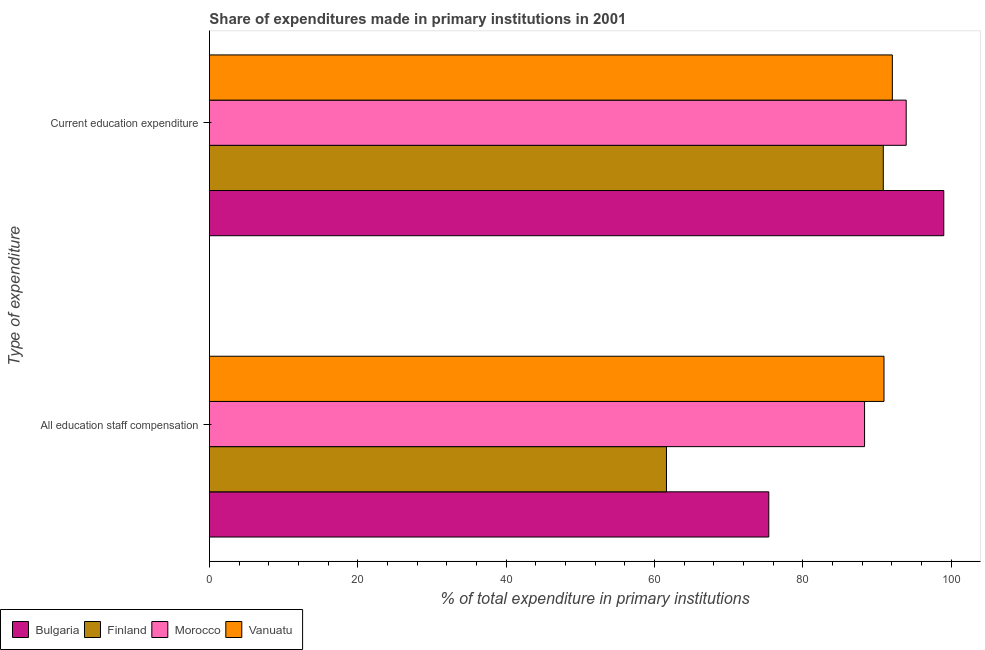How many bars are there on the 2nd tick from the bottom?
Provide a short and direct response. 4. What is the label of the 2nd group of bars from the top?
Your response must be concise. All education staff compensation. What is the expenditure in staff compensation in Morocco?
Offer a very short reply. 88.34. Across all countries, what is the maximum expenditure in staff compensation?
Ensure brevity in your answer.  90.96. Across all countries, what is the minimum expenditure in staff compensation?
Your answer should be compact. 61.63. In which country was the expenditure in staff compensation maximum?
Provide a succinct answer. Vanuatu. In which country was the expenditure in education minimum?
Your answer should be very brief. Finland. What is the total expenditure in education in the graph?
Give a very brief answer. 375.93. What is the difference between the expenditure in education in Morocco and that in Finland?
Your answer should be very brief. 3.09. What is the difference between the expenditure in education in Finland and the expenditure in staff compensation in Vanuatu?
Provide a succinct answer. -0.09. What is the average expenditure in education per country?
Keep it short and to the point. 93.98. What is the difference between the expenditure in education and expenditure in staff compensation in Morocco?
Your answer should be compact. 5.61. What is the ratio of the expenditure in education in Bulgaria to that in Finland?
Keep it short and to the point. 1.09. Is the expenditure in education in Finland less than that in Morocco?
Your answer should be compact. Yes. What does the 3rd bar from the top in All education staff compensation represents?
Provide a succinct answer. Finland. What does the 1st bar from the bottom in All education staff compensation represents?
Offer a very short reply. Bulgaria. How many bars are there?
Offer a terse response. 8. Are all the bars in the graph horizontal?
Make the answer very short. Yes. How many legend labels are there?
Provide a short and direct response. 4. How are the legend labels stacked?
Make the answer very short. Horizontal. What is the title of the graph?
Offer a very short reply. Share of expenditures made in primary institutions in 2001. Does "Bosnia and Herzegovina" appear as one of the legend labels in the graph?
Provide a short and direct response. No. What is the label or title of the X-axis?
Offer a terse response. % of total expenditure in primary institutions. What is the label or title of the Y-axis?
Ensure brevity in your answer.  Type of expenditure. What is the % of total expenditure in primary institutions of Bulgaria in All education staff compensation?
Keep it short and to the point. 75.43. What is the % of total expenditure in primary institutions in Finland in All education staff compensation?
Give a very brief answer. 61.63. What is the % of total expenditure in primary institutions of Morocco in All education staff compensation?
Your answer should be compact. 88.34. What is the % of total expenditure in primary institutions of Vanuatu in All education staff compensation?
Your response must be concise. 90.96. What is the % of total expenditure in primary institutions in Bulgaria in Current education expenditure?
Your answer should be very brief. 99.02. What is the % of total expenditure in primary institutions of Finland in Current education expenditure?
Make the answer very short. 90.87. What is the % of total expenditure in primary institutions of Morocco in Current education expenditure?
Your answer should be compact. 93.95. What is the % of total expenditure in primary institutions in Vanuatu in Current education expenditure?
Make the answer very short. 92.09. Across all Type of expenditure, what is the maximum % of total expenditure in primary institutions of Bulgaria?
Give a very brief answer. 99.02. Across all Type of expenditure, what is the maximum % of total expenditure in primary institutions in Finland?
Offer a very short reply. 90.87. Across all Type of expenditure, what is the maximum % of total expenditure in primary institutions in Morocco?
Keep it short and to the point. 93.95. Across all Type of expenditure, what is the maximum % of total expenditure in primary institutions of Vanuatu?
Provide a succinct answer. 92.09. Across all Type of expenditure, what is the minimum % of total expenditure in primary institutions in Bulgaria?
Provide a succinct answer. 75.43. Across all Type of expenditure, what is the minimum % of total expenditure in primary institutions in Finland?
Give a very brief answer. 61.63. Across all Type of expenditure, what is the minimum % of total expenditure in primary institutions of Morocco?
Make the answer very short. 88.34. Across all Type of expenditure, what is the minimum % of total expenditure in primary institutions of Vanuatu?
Your response must be concise. 90.96. What is the total % of total expenditure in primary institutions of Bulgaria in the graph?
Provide a succinct answer. 174.45. What is the total % of total expenditure in primary institutions in Finland in the graph?
Your response must be concise. 152.5. What is the total % of total expenditure in primary institutions in Morocco in the graph?
Provide a short and direct response. 182.29. What is the total % of total expenditure in primary institutions of Vanuatu in the graph?
Provide a succinct answer. 183.05. What is the difference between the % of total expenditure in primary institutions in Bulgaria in All education staff compensation and that in Current education expenditure?
Your response must be concise. -23.6. What is the difference between the % of total expenditure in primary institutions in Finland in All education staff compensation and that in Current education expenditure?
Keep it short and to the point. -29.24. What is the difference between the % of total expenditure in primary institutions in Morocco in All education staff compensation and that in Current education expenditure?
Provide a succinct answer. -5.61. What is the difference between the % of total expenditure in primary institutions of Vanuatu in All education staff compensation and that in Current education expenditure?
Make the answer very short. -1.13. What is the difference between the % of total expenditure in primary institutions of Bulgaria in All education staff compensation and the % of total expenditure in primary institutions of Finland in Current education expenditure?
Provide a succinct answer. -15.44. What is the difference between the % of total expenditure in primary institutions in Bulgaria in All education staff compensation and the % of total expenditure in primary institutions in Morocco in Current education expenditure?
Ensure brevity in your answer.  -18.53. What is the difference between the % of total expenditure in primary institutions of Bulgaria in All education staff compensation and the % of total expenditure in primary institutions of Vanuatu in Current education expenditure?
Make the answer very short. -16.66. What is the difference between the % of total expenditure in primary institutions in Finland in All education staff compensation and the % of total expenditure in primary institutions in Morocco in Current education expenditure?
Make the answer very short. -32.32. What is the difference between the % of total expenditure in primary institutions of Finland in All education staff compensation and the % of total expenditure in primary institutions of Vanuatu in Current education expenditure?
Your response must be concise. -30.46. What is the difference between the % of total expenditure in primary institutions in Morocco in All education staff compensation and the % of total expenditure in primary institutions in Vanuatu in Current education expenditure?
Give a very brief answer. -3.75. What is the average % of total expenditure in primary institutions in Bulgaria per Type of expenditure?
Your answer should be compact. 87.22. What is the average % of total expenditure in primary institutions in Finland per Type of expenditure?
Provide a short and direct response. 76.25. What is the average % of total expenditure in primary institutions in Morocco per Type of expenditure?
Offer a very short reply. 91.15. What is the average % of total expenditure in primary institutions in Vanuatu per Type of expenditure?
Offer a very short reply. 91.52. What is the difference between the % of total expenditure in primary institutions in Bulgaria and % of total expenditure in primary institutions in Finland in All education staff compensation?
Your answer should be very brief. 13.8. What is the difference between the % of total expenditure in primary institutions in Bulgaria and % of total expenditure in primary institutions in Morocco in All education staff compensation?
Your answer should be compact. -12.91. What is the difference between the % of total expenditure in primary institutions of Bulgaria and % of total expenditure in primary institutions of Vanuatu in All education staff compensation?
Your answer should be very brief. -15.53. What is the difference between the % of total expenditure in primary institutions in Finland and % of total expenditure in primary institutions in Morocco in All education staff compensation?
Ensure brevity in your answer.  -26.71. What is the difference between the % of total expenditure in primary institutions in Finland and % of total expenditure in primary institutions in Vanuatu in All education staff compensation?
Your answer should be compact. -29.33. What is the difference between the % of total expenditure in primary institutions of Morocco and % of total expenditure in primary institutions of Vanuatu in All education staff compensation?
Your response must be concise. -2.62. What is the difference between the % of total expenditure in primary institutions in Bulgaria and % of total expenditure in primary institutions in Finland in Current education expenditure?
Offer a terse response. 8.15. What is the difference between the % of total expenditure in primary institutions of Bulgaria and % of total expenditure in primary institutions of Morocco in Current education expenditure?
Ensure brevity in your answer.  5.07. What is the difference between the % of total expenditure in primary institutions in Bulgaria and % of total expenditure in primary institutions in Vanuatu in Current education expenditure?
Your answer should be very brief. 6.94. What is the difference between the % of total expenditure in primary institutions of Finland and % of total expenditure in primary institutions of Morocco in Current education expenditure?
Your answer should be very brief. -3.09. What is the difference between the % of total expenditure in primary institutions of Finland and % of total expenditure in primary institutions of Vanuatu in Current education expenditure?
Your response must be concise. -1.22. What is the difference between the % of total expenditure in primary institutions in Morocco and % of total expenditure in primary institutions in Vanuatu in Current education expenditure?
Offer a very short reply. 1.87. What is the ratio of the % of total expenditure in primary institutions in Bulgaria in All education staff compensation to that in Current education expenditure?
Offer a terse response. 0.76. What is the ratio of the % of total expenditure in primary institutions in Finland in All education staff compensation to that in Current education expenditure?
Your answer should be compact. 0.68. What is the ratio of the % of total expenditure in primary institutions of Morocco in All education staff compensation to that in Current education expenditure?
Provide a short and direct response. 0.94. What is the ratio of the % of total expenditure in primary institutions in Vanuatu in All education staff compensation to that in Current education expenditure?
Give a very brief answer. 0.99. What is the difference between the highest and the second highest % of total expenditure in primary institutions in Bulgaria?
Keep it short and to the point. 23.6. What is the difference between the highest and the second highest % of total expenditure in primary institutions in Finland?
Offer a terse response. 29.24. What is the difference between the highest and the second highest % of total expenditure in primary institutions in Morocco?
Give a very brief answer. 5.61. What is the difference between the highest and the second highest % of total expenditure in primary institutions of Vanuatu?
Your answer should be very brief. 1.13. What is the difference between the highest and the lowest % of total expenditure in primary institutions in Bulgaria?
Your answer should be very brief. 23.6. What is the difference between the highest and the lowest % of total expenditure in primary institutions in Finland?
Offer a very short reply. 29.24. What is the difference between the highest and the lowest % of total expenditure in primary institutions of Morocco?
Ensure brevity in your answer.  5.61. What is the difference between the highest and the lowest % of total expenditure in primary institutions of Vanuatu?
Make the answer very short. 1.13. 